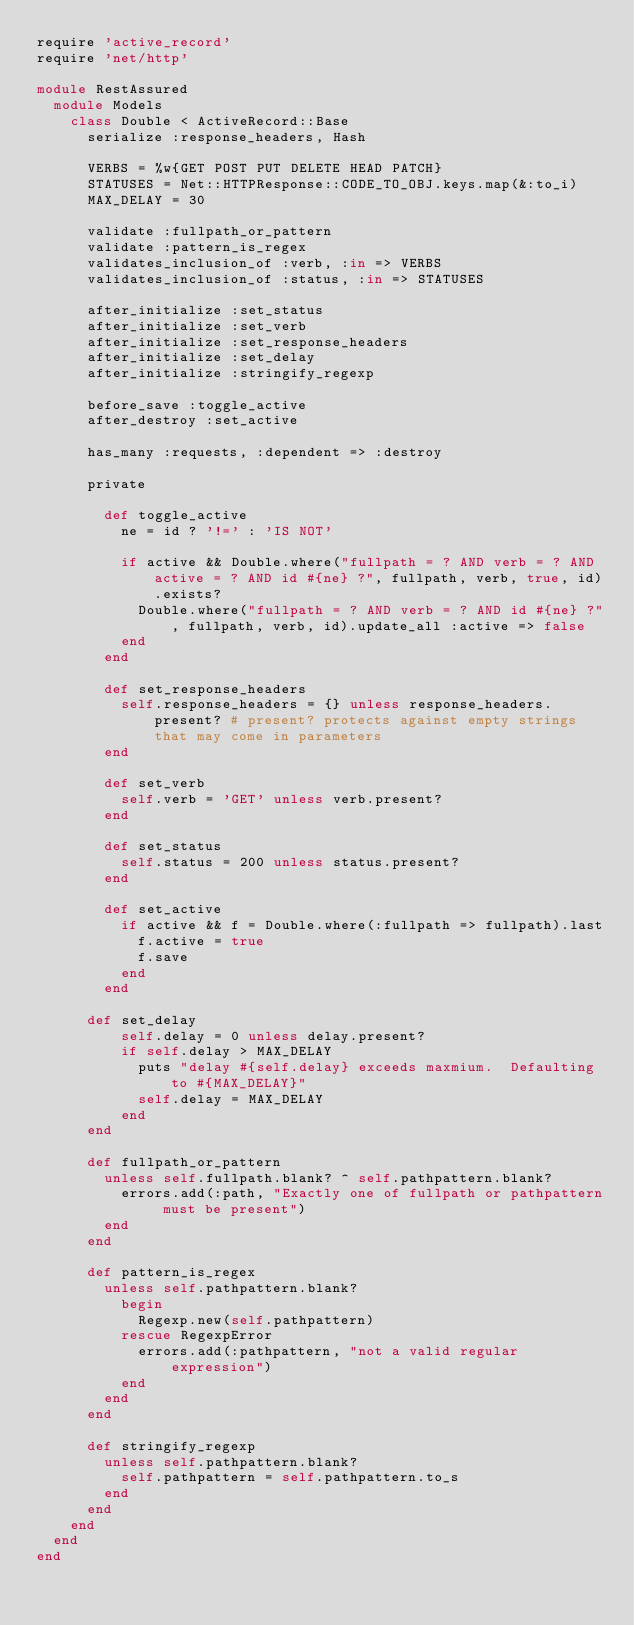Convert code to text. <code><loc_0><loc_0><loc_500><loc_500><_Ruby_>require 'active_record'
require 'net/http'

module RestAssured
  module Models
    class Double < ActiveRecord::Base
      serialize :response_headers, Hash

      VERBS = %w{GET POST PUT DELETE HEAD PATCH}
      STATUSES = Net::HTTPResponse::CODE_TO_OBJ.keys.map(&:to_i)
      MAX_DELAY = 30

      validate :fullpath_or_pattern
      validate :pattern_is_regex
      validates_inclusion_of :verb, :in => VERBS
      validates_inclusion_of :status, :in => STATUSES

      after_initialize :set_status
      after_initialize :set_verb
      after_initialize :set_response_headers
      after_initialize :set_delay
      after_initialize :stringify_regexp

      before_save :toggle_active
      after_destroy :set_active

      has_many :requests, :dependent => :destroy

      private

        def toggle_active
          ne = id ? '!=' : 'IS NOT'

          if active && Double.where("fullpath = ? AND verb = ? AND active = ? AND id #{ne} ?", fullpath, verb, true, id).exists?
            Double.where("fullpath = ? AND verb = ? AND id #{ne} ?", fullpath, verb, id).update_all :active => false
          end
        end

        def set_response_headers
          self.response_headers = {} unless response_headers.present? # present? protects against empty strings that may come in parameters
        end

        def set_verb
          self.verb = 'GET' unless verb.present?
        end

        def set_status
          self.status = 200 unless status.present?
        end

        def set_active
          if active && f = Double.where(:fullpath => fullpath).last
            f.active = true
            f.save
          end
        end

      def set_delay
          self.delay = 0 unless delay.present?
          if self.delay > MAX_DELAY
            puts "delay #{self.delay} exceeds maxmium.  Defaulting to #{MAX_DELAY}"
            self.delay = MAX_DELAY
          end
      end

      def fullpath_or_pattern
        unless self.fullpath.blank? ^ self.pathpattern.blank?
          errors.add(:path, "Exactly one of fullpath or pathpattern must be present")
        end
      end

      def pattern_is_regex
        unless self.pathpattern.blank?
          begin
            Regexp.new(self.pathpattern)
          rescue RegexpError
            errors.add(:pathpattern, "not a valid regular expression")
          end
        end
      end

      def stringify_regexp
        unless self.pathpattern.blank?
          self.pathpattern = self.pathpattern.to_s
        end
      end
    end
  end
end
</code> 